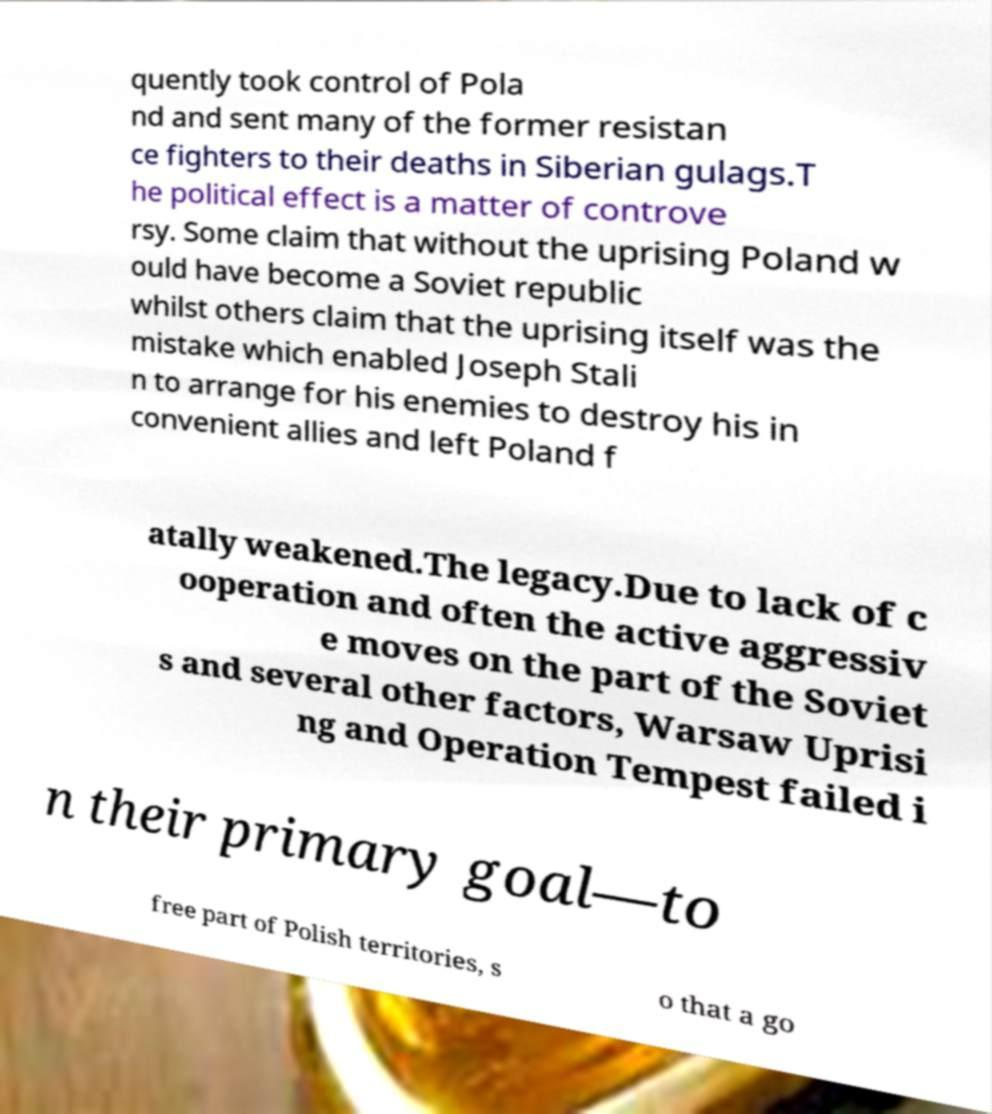Can you read and provide the text displayed in the image?This photo seems to have some interesting text. Can you extract and type it out for me? quently took control of Pola nd and sent many of the former resistan ce fighters to their deaths in Siberian gulags.T he political effect is a matter of controve rsy. Some claim that without the uprising Poland w ould have become a Soviet republic whilst others claim that the uprising itself was the mistake which enabled Joseph Stali n to arrange for his enemies to destroy his in convenient allies and left Poland f atally weakened.The legacy.Due to lack of c ooperation and often the active aggressiv e moves on the part of the Soviet s and several other factors, Warsaw Uprisi ng and Operation Tempest failed i n their primary goal—to free part of Polish territories, s o that a go 